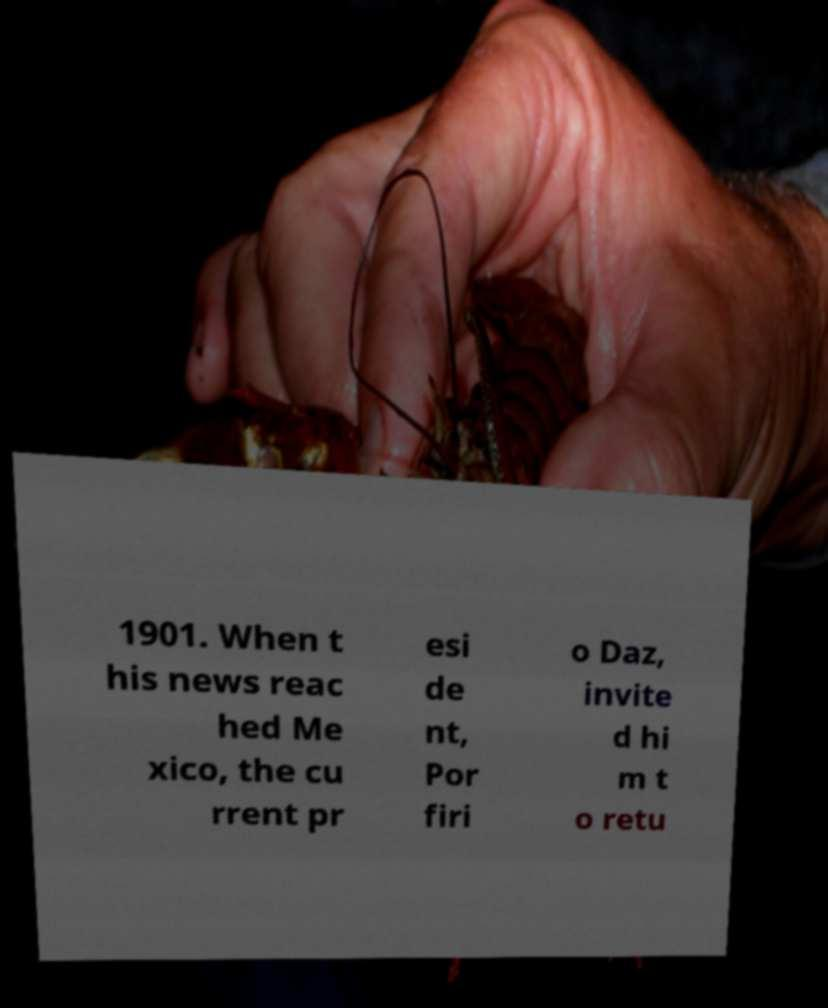What messages or text are displayed in this image? I need them in a readable, typed format. 1901. When t his news reac hed Me xico, the cu rrent pr esi de nt, Por firi o Daz, invite d hi m t o retu 